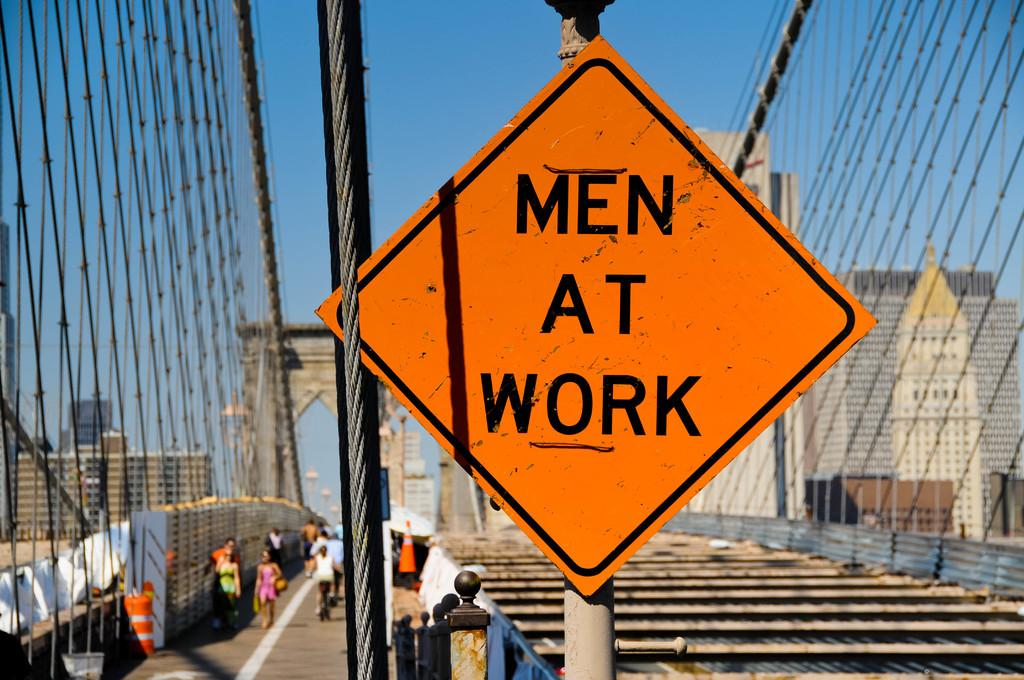<image>
Create a compact narrative representing the image presented. The big yellow sign reads Men At Work 